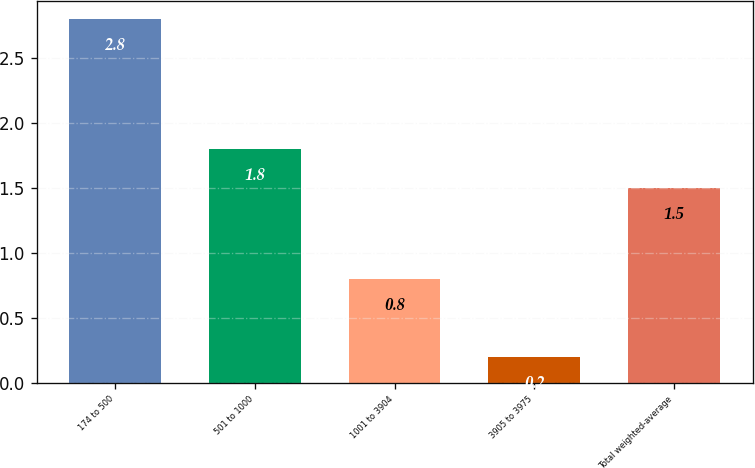Convert chart to OTSL. <chart><loc_0><loc_0><loc_500><loc_500><bar_chart><fcel>174 to 500<fcel>501 to 1000<fcel>1001 to 3904<fcel>3905 to 3975<fcel>Total weighted-average<nl><fcel>2.8<fcel>1.8<fcel>0.8<fcel>0.2<fcel>1.5<nl></chart> 